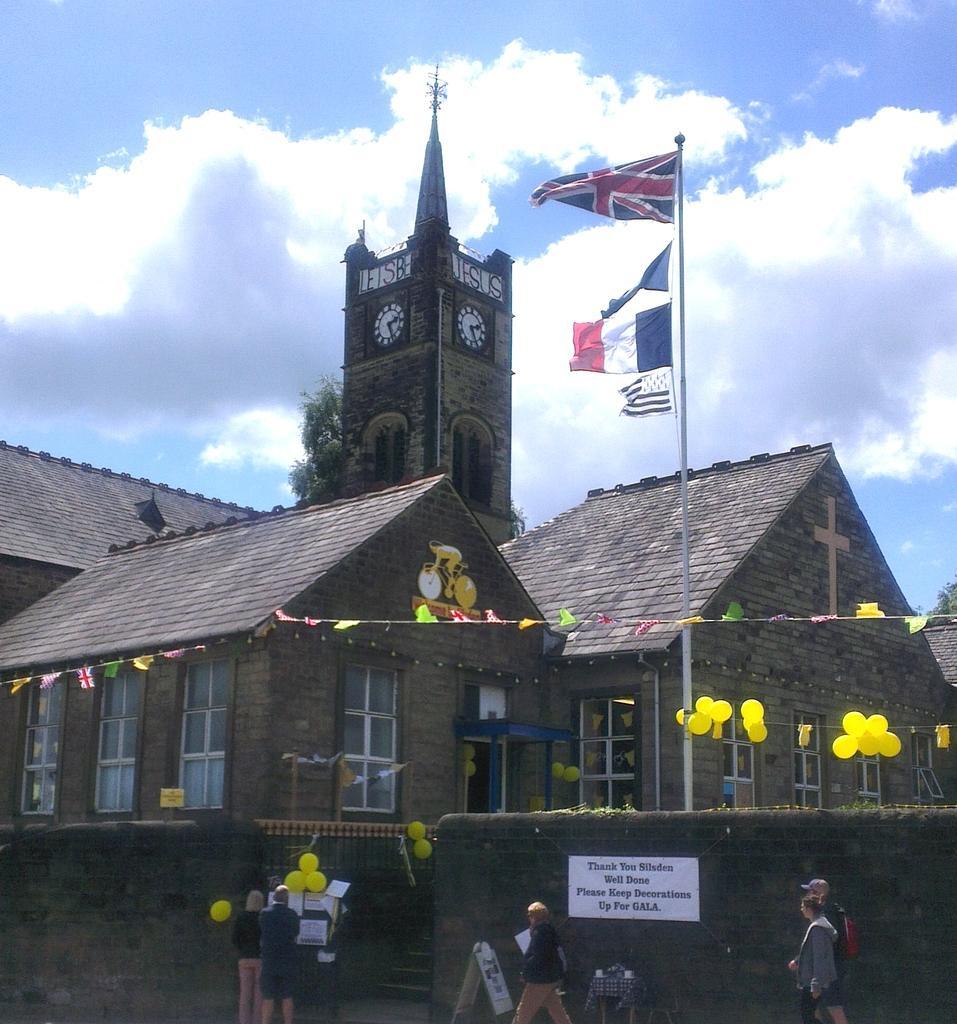In one or two sentences, can you explain what this image depicts? In the image there is a building with a tower behind it and a clock in middle of it, in the front there is a flag with balloons hanging to it, in the front there are few people standing and walking on the road and above its sky with clouds. 